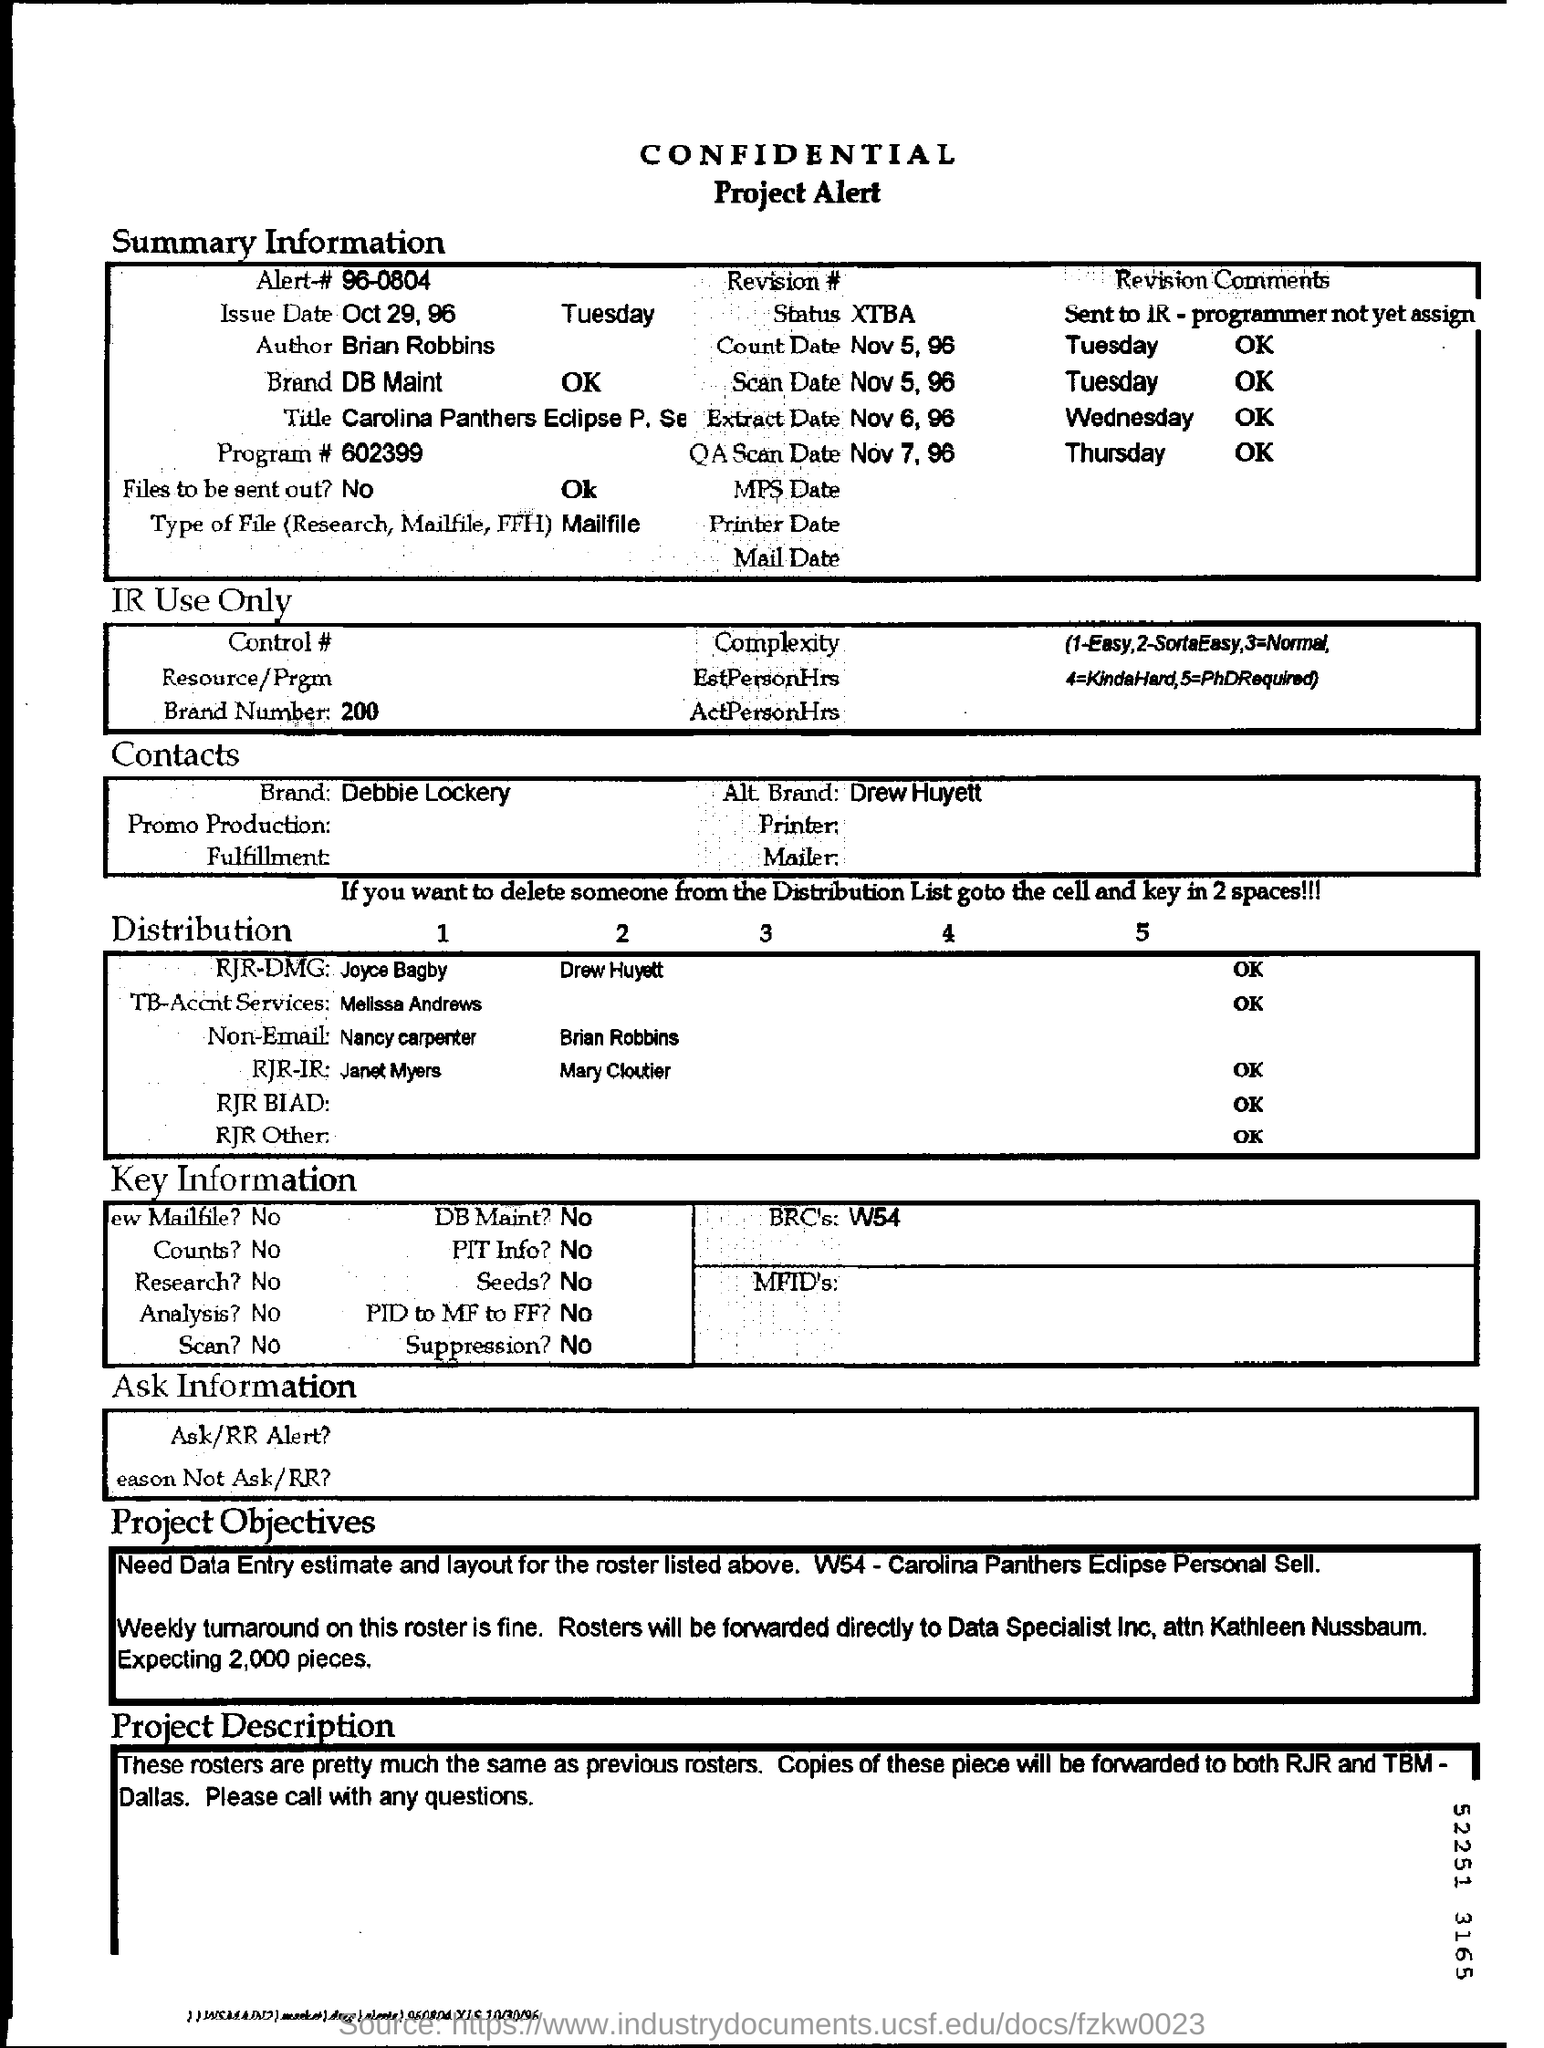Mention a couple of crucial points in this snapshot. The files are not intended to be sent out. The heading of this document is CONFIDENTIAL, indicating its sensitive nature. The brand mentioned in the summary information is DB Maint. The author of this document is Brian Robbins. 